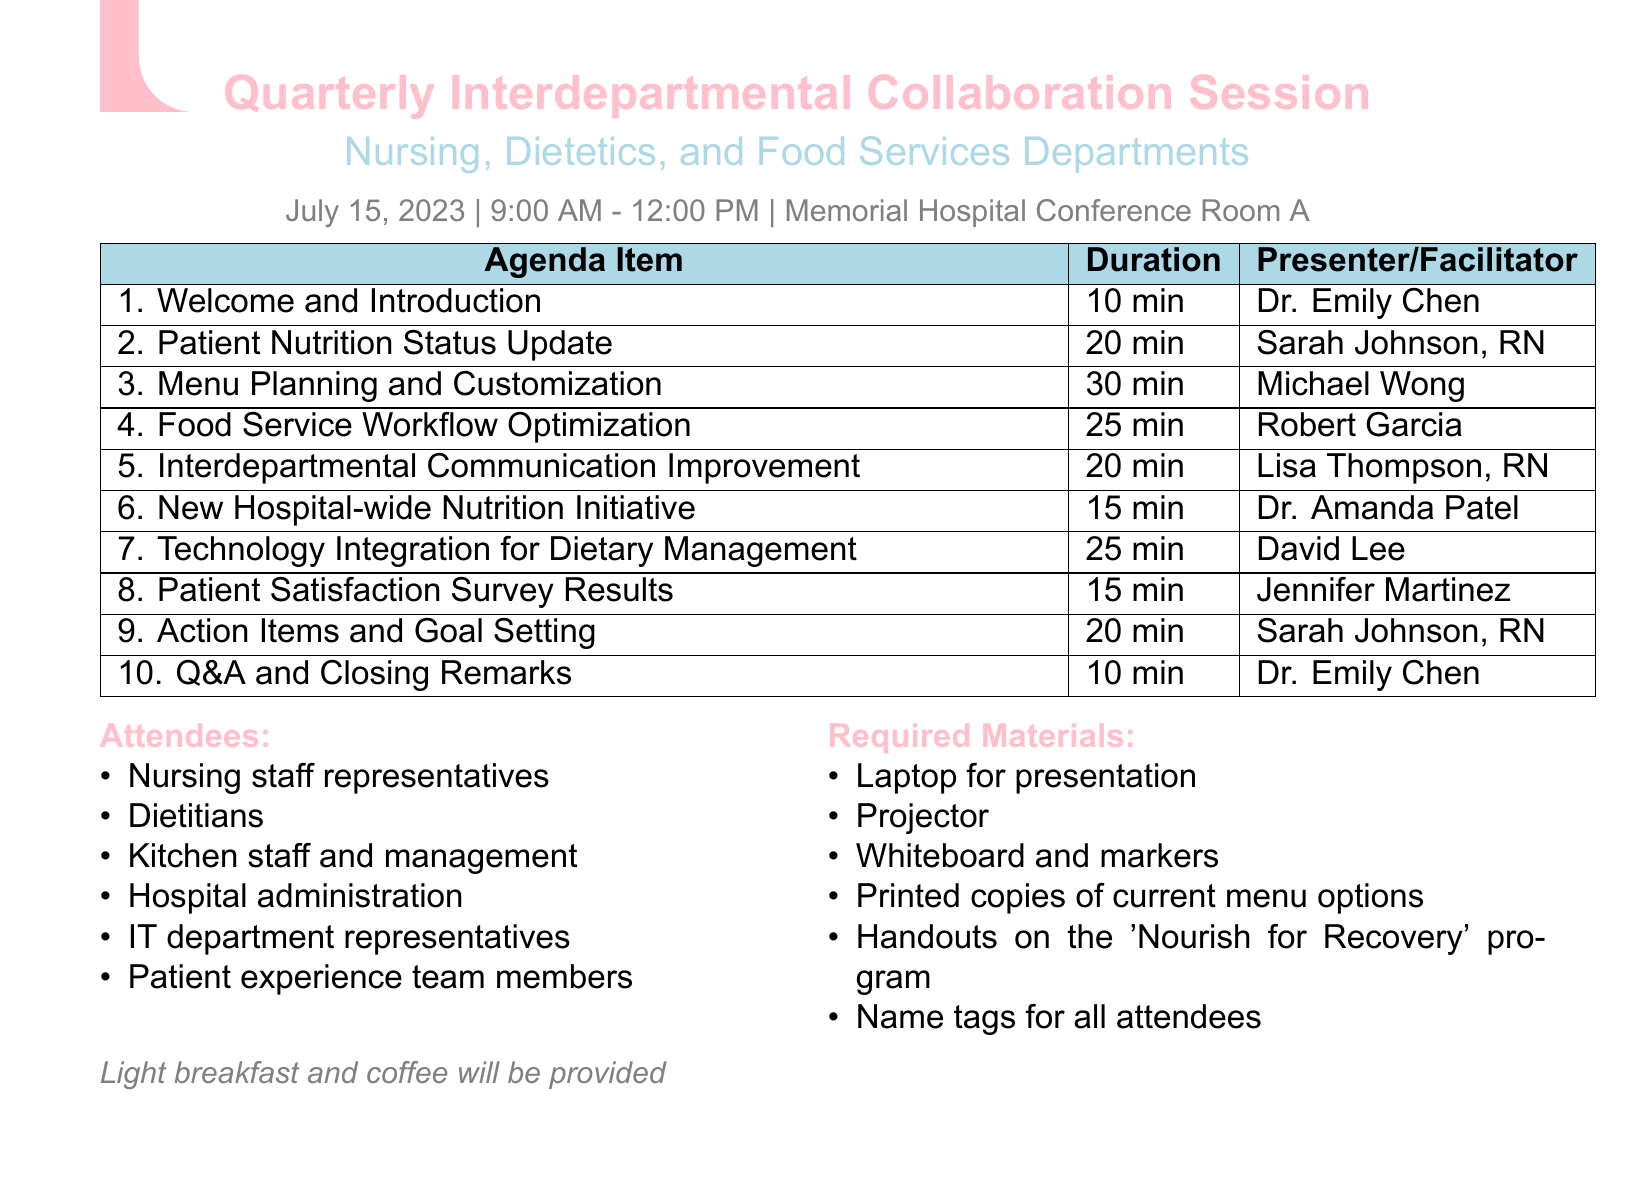What is the date of the session? The date of the session is specified in the logistics section of the document.
Answer: July 15, 2023 Who is presenting the "Menu Planning and Customization" agenda item? The presenter for this agenda item is listed in the agenda items section of the document.
Answer: Michael Wong How long is the "Patient Nutrition Status Update" discussion? The duration is provided in the agenda items section.
Answer: 20 minutes What is the name of the new hospital-wide nutrition initiative? The name of the initiative is found in the agenda items section.
Answer: Nourish for Recovery Which role does Lisa Thompson hold? Lisa Thompson's role is mentioned in the agenda items section under the facilitator for communication improvement.
Answer: RN, Nursing Director What materials are required for the session? The required materials are specified in a dedicated section of the document.
Answer: Laptop for presentation How many attendees are listed? The list of attendees is provided in a specific section in the document.
Answer: Six What time does the session start? The starting time of the session is mentioned in the logistics section.
Answer: 9:00 AM Who moderated the Q&A and Closing Remarks? The name of the moderator is given in the agenda items section.
Answer: Dr. Emily Chen 